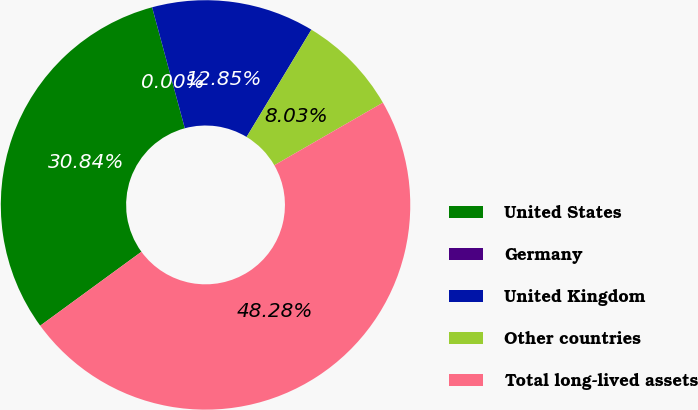Convert chart. <chart><loc_0><loc_0><loc_500><loc_500><pie_chart><fcel>United States<fcel>Germany<fcel>United Kingdom<fcel>Other countries<fcel>Total long-lived assets<nl><fcel>30.84%<fcel>0.0%<fcel>12.85%<fcel>8.03%<fcel>48.28%<nl></chart> 